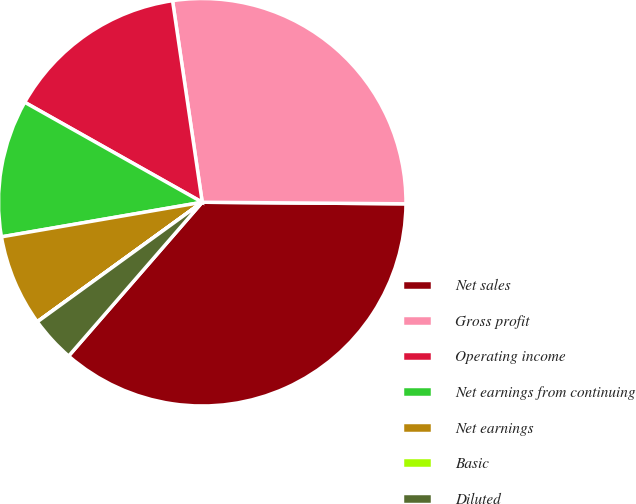Convert chart to OTSL. <chart><loc_0><loc_0><loc_500><loc_500><pie_chart><fcel>Net sales<fcel>Gross profit<fcel>Operating income<fcel>Net earnings from continuing<fcel>Net earnings<fcel>Basic<fcel>Diluted<nl><fcel>36.26%<fcel>27.45%<fcel>14.51%<fcel>10.88%<fcel>7.26%<fcel>0.01%<fcel>3.63%<nl></chart> 